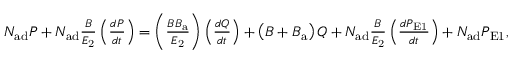<formula> <loc_0><loc_0><loc_500><loc_500>\begin{array} { r } { N _ { a d } P + N _ { a d } \frac { B } { E _ { 2 } } \left ( \frac { d P } { d t } \right ) = \left ( \frac { B B _ { a } } { E _ { 2 } } \right ) \left ( \frac { d Q } { d t } \right ) + \left ( B + B _ { a } \right ) Q + N _ { a d } \frac { B } { E _ { 2 } } \left ( \frac { d P _ { E 1 } } { d t } \right ) + N _ { a d } P _ { E 1 } , } \end{array}</formula> 